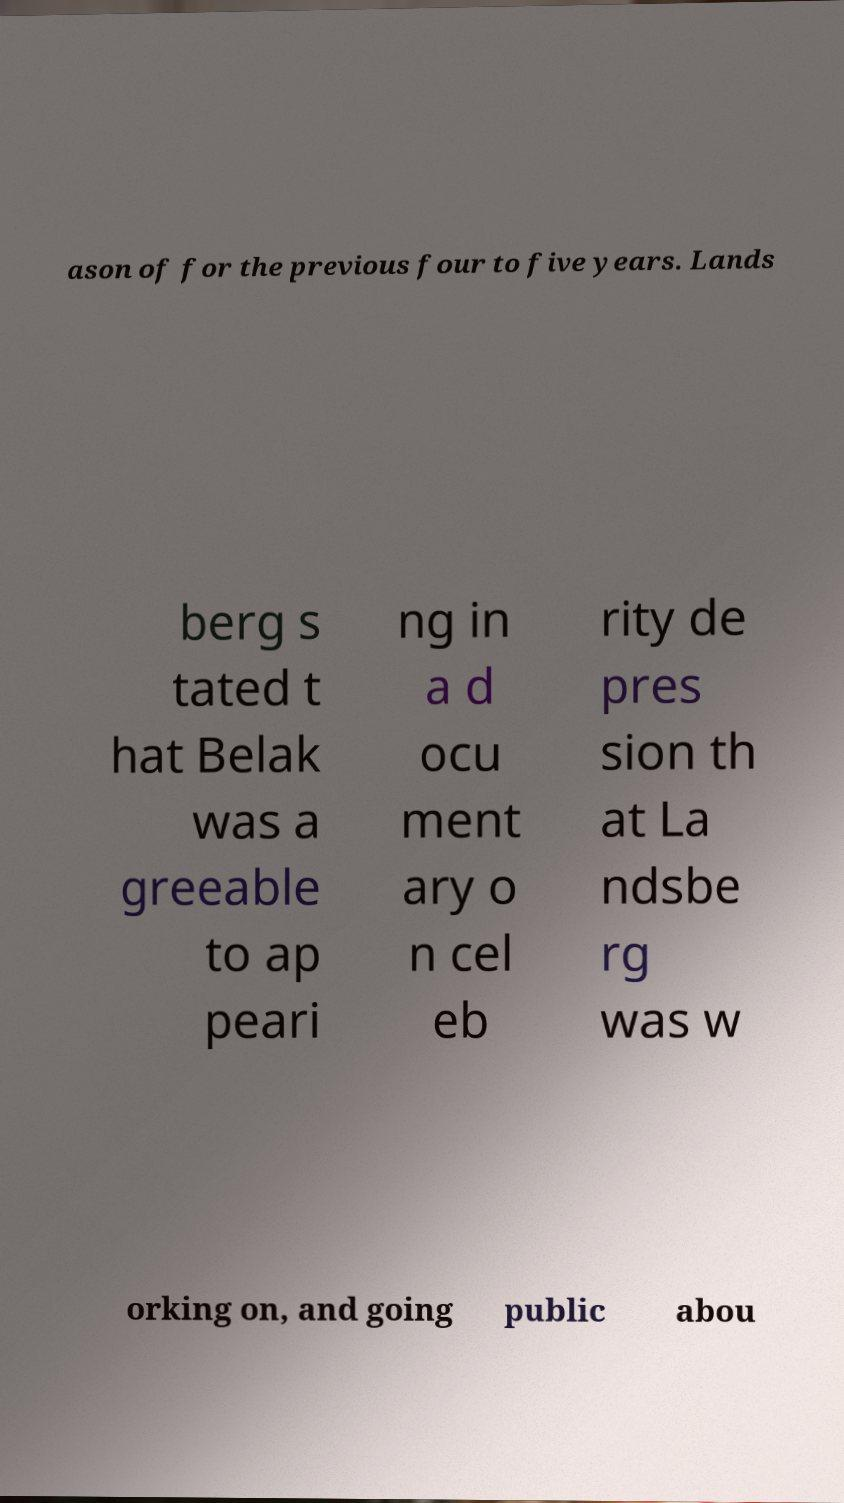There's text embedded in this image that I need extracted. Can you transcribe it verbatim? ason of for the previous four to five years. Lands berg s tated t hat Belak was a greeable to ap peari ng in a d ocu ment ary o n cel eb rity de pres sion th at La ndsbe rg was w orking on, and going public abou 